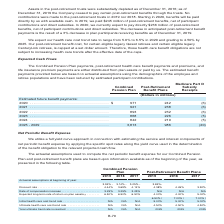According to Centurylink's financial document, Which payments are either distributed from plan assets or paid by the company? The Combined Pension Plan payments, post-retirement health care benefit payments and premiums, and life insurance premium payments. The document states: "The Combined Pension Plan payments, post-retirement health care benefit payments and premiums, and life insurance premium payments are either distribu..." Also, What assumptions are the estimated benefit payments based on? actuarial assumptions using the demographics of the employee and retiree populations and have been reduced by estimated participant contributions. The document states: "ated benefit payments provided below are based on actuarial assumptions using the demographics of the employee and retiree populations and have been r..." Also, What are the different periods highlighted in the table? The document contains multiple relevant values: 2020, 2021, 2022, 2023, 2024, 2025-2029. From the document: "payments: 2020 . $ 971 242 (6) 2021 . 921 238 (6) 2022 . 893 232 (6) 2023 . 868 226 (5) 2024 . 842 219 (5) 2025 - 2029 . 3,813 986 (20) 971 242 (6) 20..." Also, How many different period segments are highlighted in the table? Counting the relevant items in the document: 2020, 2021, 2022, 2023, 2024, 2025-2029, I find 6 instances. The key data points involved are: 2020, 2021, 2022. Also, can you calculate: What is the change in combined pension plan in 2021 from 2020? Based on the calculation: 921-971, the result is -50 (in millions). This is based on the information: "ure benefit payments: 2020 . $ 971 242 (6) 2021 . 921 238 (6) 2022 . 893 232 (6) 2023 . 868 226 (5) 2024 . 842 219 (5) 2025 - 2029 . 3,813 986 (20) ions) Estimated future benefit payments: 2020 . $ 97..." The key data points involved are: 921, 971. Also, can you calculate: What is the percentage change in combined pension plan in 2021 from 2020? To answer this question, I need to perform calculations using the financial data. The calculation is: (921-971)/971, which equals -5.15 (percentage). This is based on the information: "ure benefit payments: 2020 . $ 971 242 (6) 2021 . 921 238 (6) 2022 . 893 232 (6) 2023 . 868 226 (5) 2024 . 842 219 (5) 2025 - 2029 . 3,813 986 (20) ions) Estimated future benefit payments: 2020 . $ 97..." The key data points involved are: 921, 971. 